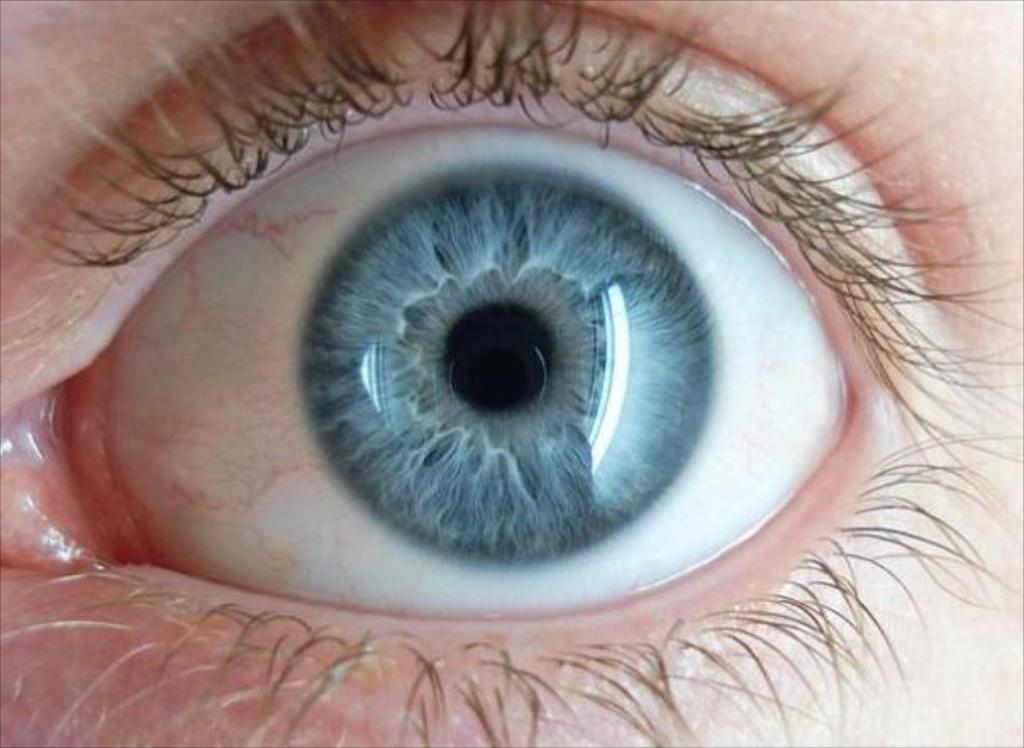What is the main subject of the image? The main subject of the image is an eye. What can be seen around the eye in the image? Eyelashes are visible in the image. What type of linen is being used to cover the baby in the image? There is no baby or linen present in the image; it only features an eye and eyelashes. 